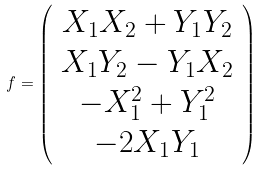<formula> <loc_0><loc_0><loc_500><loc_500>f = \left ( \begin{array} { c c } X _ { 1 } X _ { 2 } + Y _ { 1 } Y _ { 2 } \\ X _ { 1 } Y _ { 2 } - Y _ { 1 } X _ { 2 } \\ - X ^ { 2 } _ { 1 } + Y ^ { 2 } _ { 1 } \\ - 2 X _ { 1 } Y _ { 1 } \end{array} \right )</formula> 